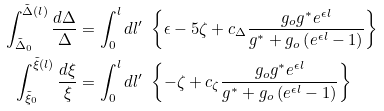<formula> <loc_0><loc_0><loc_500><loc_500>\int _ { \tilde { \Delta } _ { 0 } } ^ { \tilde { \Delta } ( l ) } \frac { d \Delta } \Delta & = \int _ { 0 } ^ { l } d l ^ { \prime } \ \left \{ \epsilon - 5 \zeta + c _ { \Delta } \frac { g _ { o } g ^ { * } e ^ { \epsilon l } } { g ^ { * } + g _ { o } \left ( e ^ { \epsilon l } - 1 \right ) } \right \} \\ \int _ { \tilde { \xi } _ { 0 } } ^ { \tilde { \xi } ( l ) } \frac { d \xi } \xi & = \int _ { 0 } ^ { l } d l ^ { \prime } \ \left \{ - \zeta + c _ { \zeta } \frac { g _ { o } g ^ { * } e ^ { \epsilon l } } { g ^ { * } + g _ { o } \left ( e ^ { \epsilon l } - 1 \right ) } \right \}</formula> 